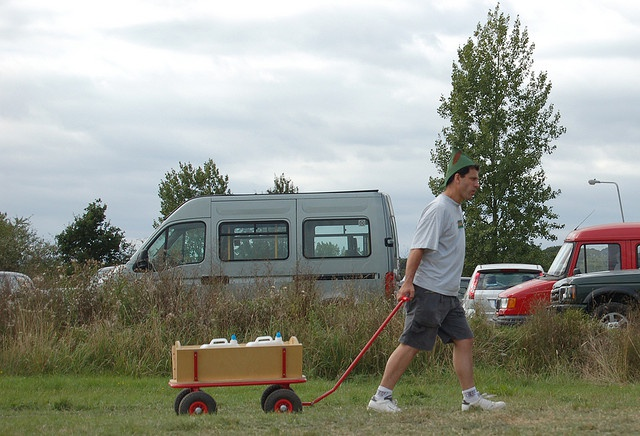Describe the objects in this image and their specific colors. I can see truck in white, gray, darkgray, and black tones, car in white, gray, darkgray, and black tones, people in white, black, darkgray, gray, and brown tones, truck in white, gray, brown, maroon, and darkgray tones, and truck in white, black, gray, and purple tones in this image. 